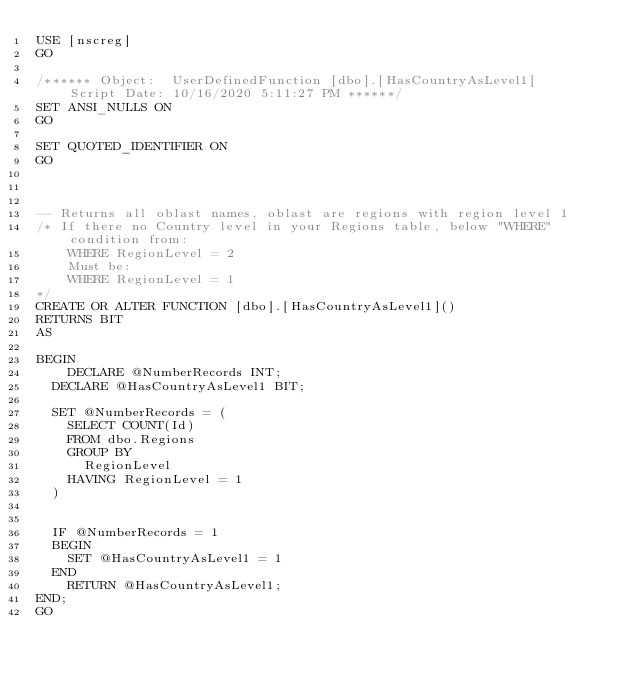Convert code to text. <code><loc_0><loc_0><loc_500><loc_500><_SQL_>USE [nscreg]
GO

/****** Object:  UserDefinedFunction [dbo].[HasCountryAsLevel1]    Script Date: 10/16/2020 5:11:27 PM ******/
SET ANSI_NULLS ON
GO

SET QUOTED_IDENTIFIER ON
GO



-- Returns all oblast names, oblast are regions with region level 1
/* If there no Country level in your Regions table, below "WHERE" condition from:
    WHERE RegionLevel = 2
    Must be:
    WHERE RegionLevel = 1
*/
CREATE OR ALTER FUNCTION [dbo].[HasCountryAsLevel1]()  
RETURNS BIT
AS   

BEGIN  
    DECLARE @NumberRecords INT;
	DECLARE @HasCountryAsLevel1 BIT;

	SET @NumberRecords = (
		SELECT COUNT(Id)
		FROM dbo.Regions  
		GROUP BY 
			RegionLevel
		HAVING RegionLevel = 1
	)
	

	IF @NumberRecords = 1
	BEGIN
		SET @HasCountryAsLevel1 = 1
	END
    RETURN @HasCountryAsLevel1;  
END; 
GO

</code> 